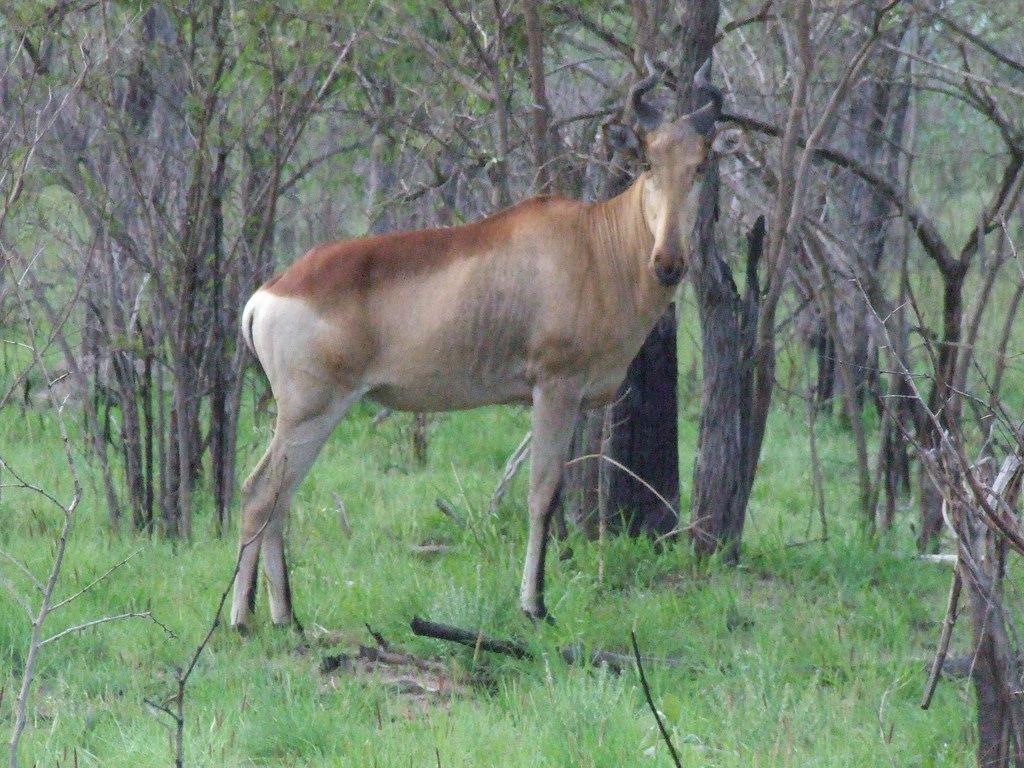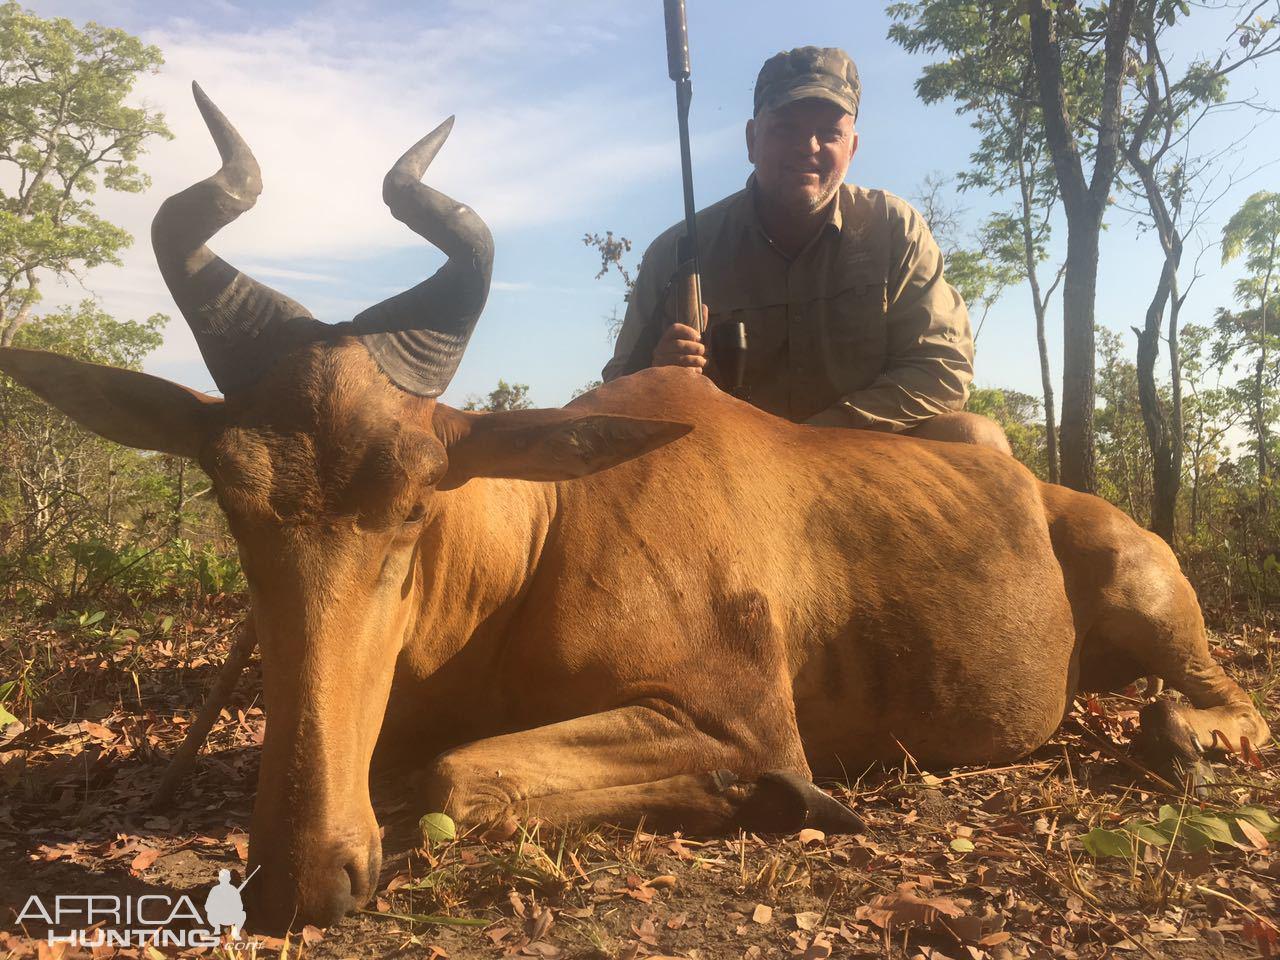The first image is the image on the left, the second image is the image on the right. Assess this claim about the two images: "The left and right image contains the same number of right facing antelopes.". Correct or not? Answer yes or no. No. The first image is the image on the left, the second image is the image on the right. For the images shown, is this caption "One animal is heading left with their head turned and looking into the camera." true? Answer yes or no. No. 